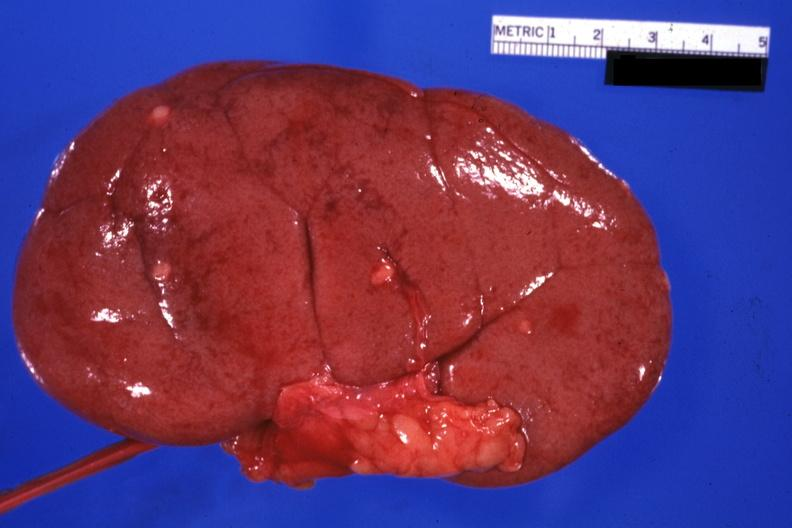s metastatic carcinoma breast present?
Answer the question using a single word or phrase. Yes 